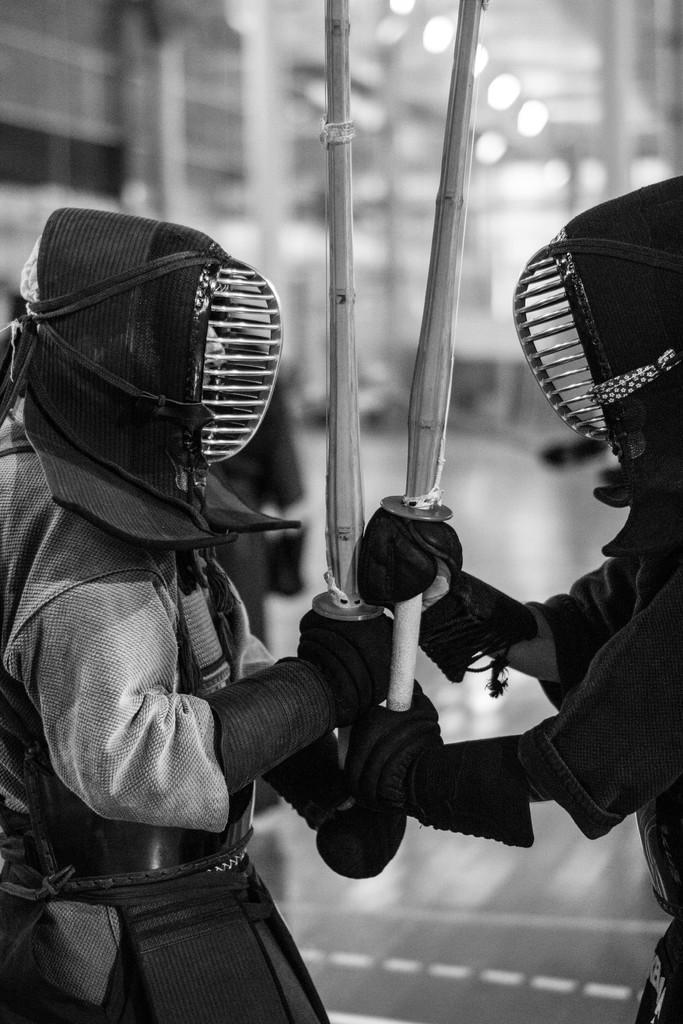Describe this image in one or two sentences. In this image I can see the black and white picture in which I can see two persons wearing costumes and holding sticks in their hands. I can see the blurry background. 